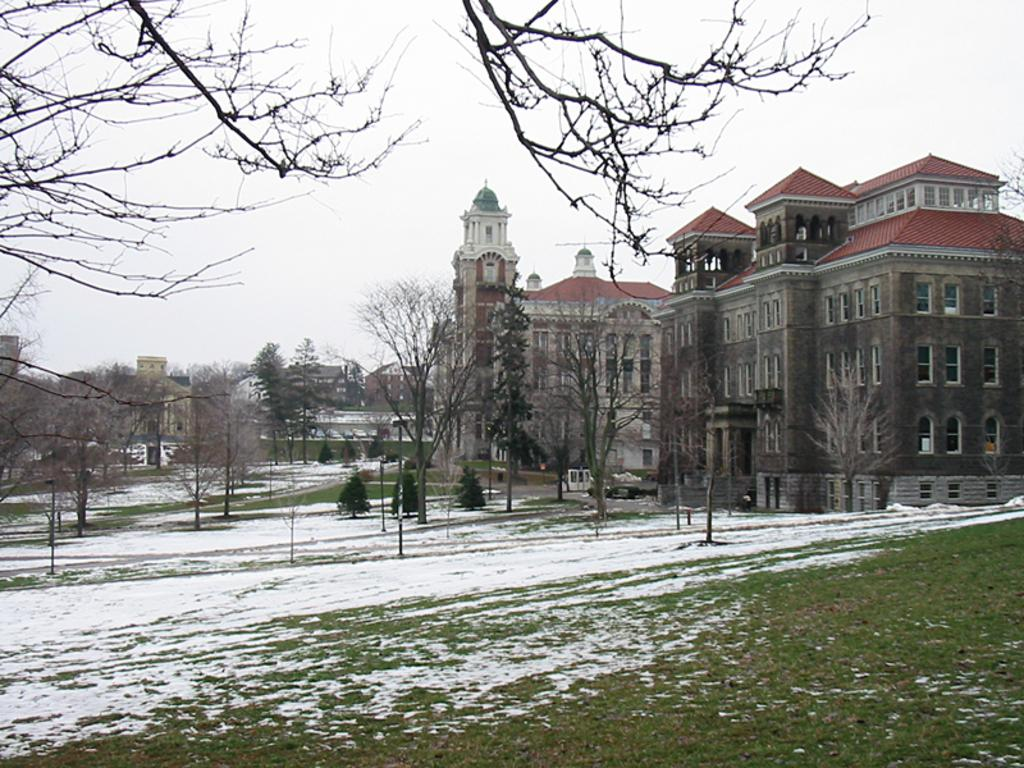What is the condition of the grassland in the image? The grassland is covered with snow. What can be seen in the background of the image? There are trees and buildings in the background of the image. What is visible above the grassland and background elements? The sky is visible in the background of the image. What type of behavior can be observed in the tank in the image? There is no tank present in the image; it features a snow-covered grassland with trees and buildings in the background. 